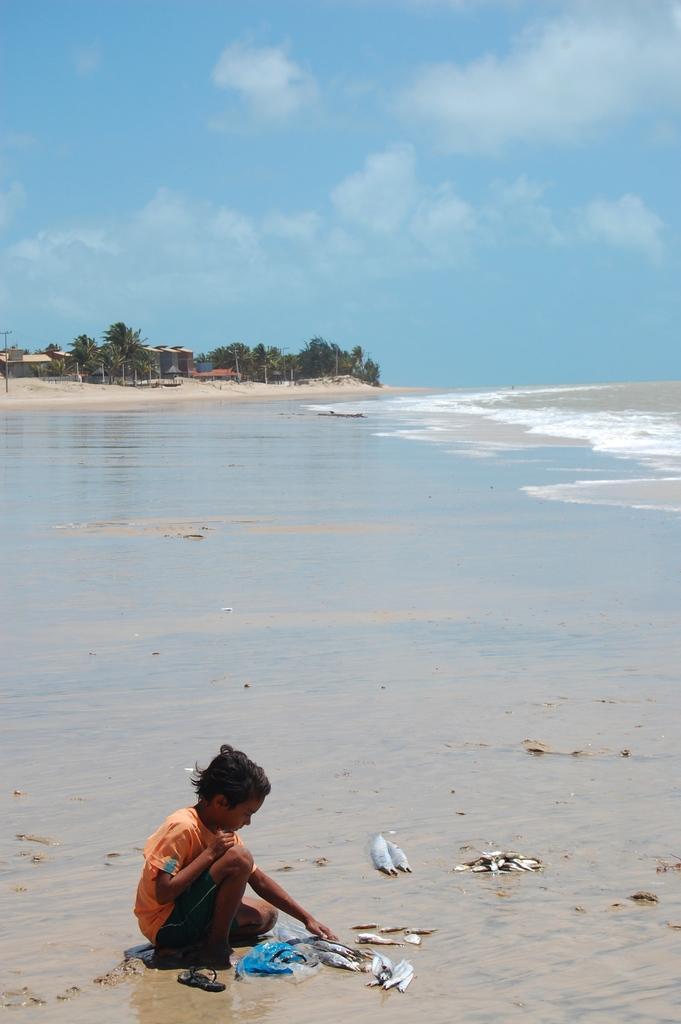How would you summarize this image in a sentence or two? At the bottom of the image a boy is sitting and holding some fishes. Behind him there is water. In the middle of the image there are some trees and huts. At the top of the image there are some clouds and sky. 